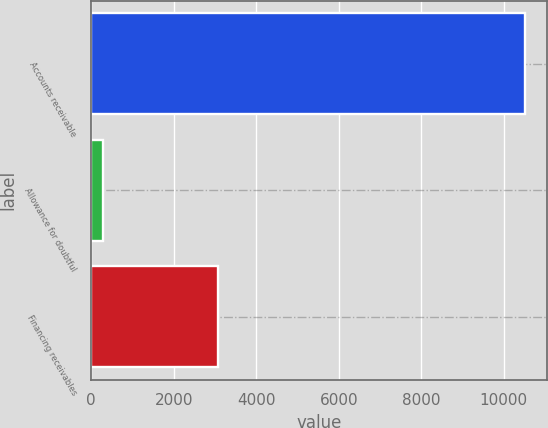<chart> <loc_0><loc_0><loc_500><loc_500><bar_chart><fcel>Accounts receivable<fcel>Allowance for doubtful<fcel>Financing receivables<nl><fcel>10512<fcel>286<fcel>3066<nl></chart> 